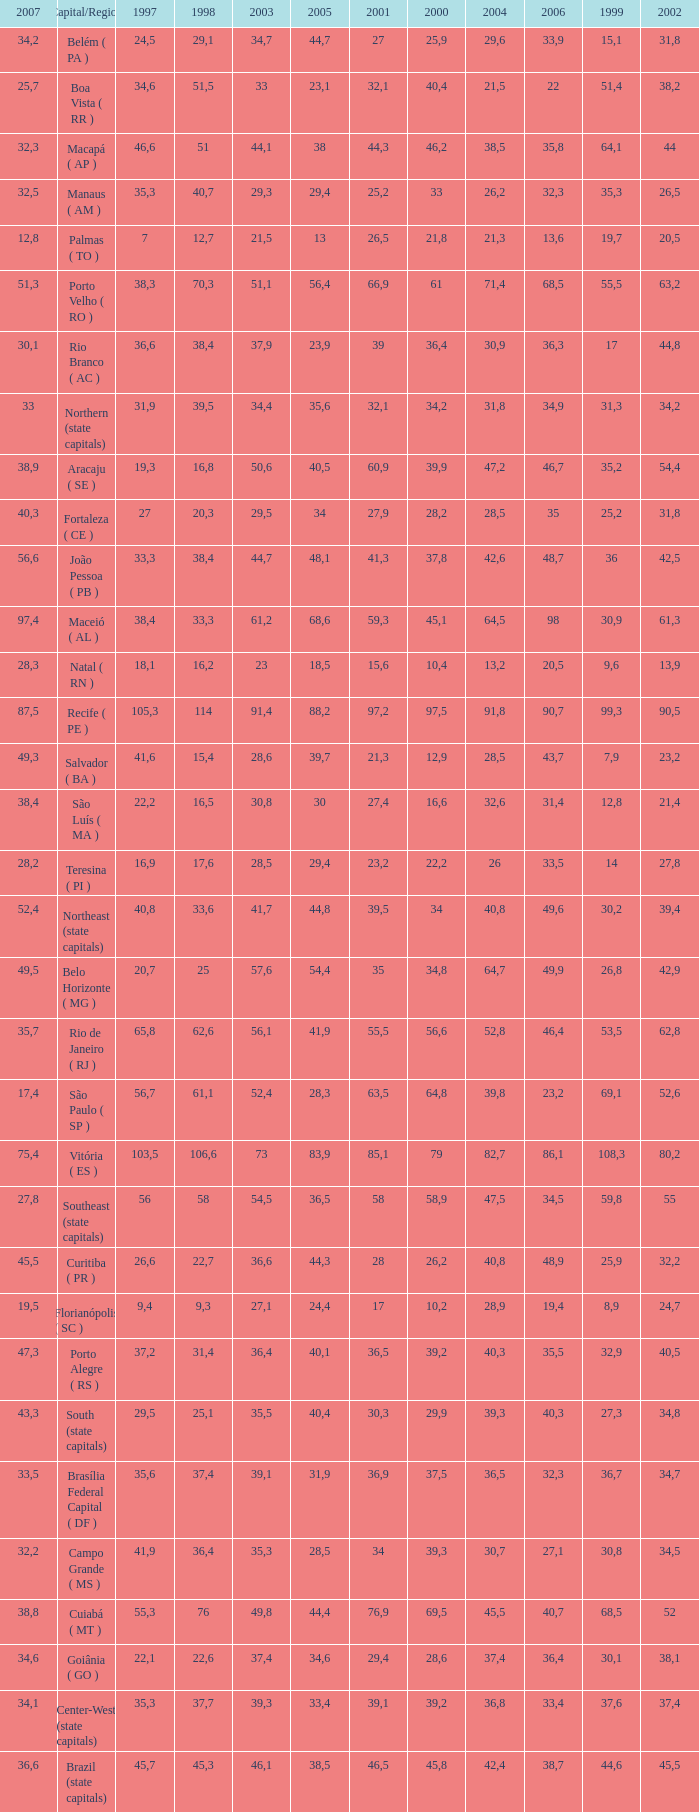How many 2007's have a 2000 greater than 56,6, 23,2 as 2006, and a 1998 greater than 61,1? None. 